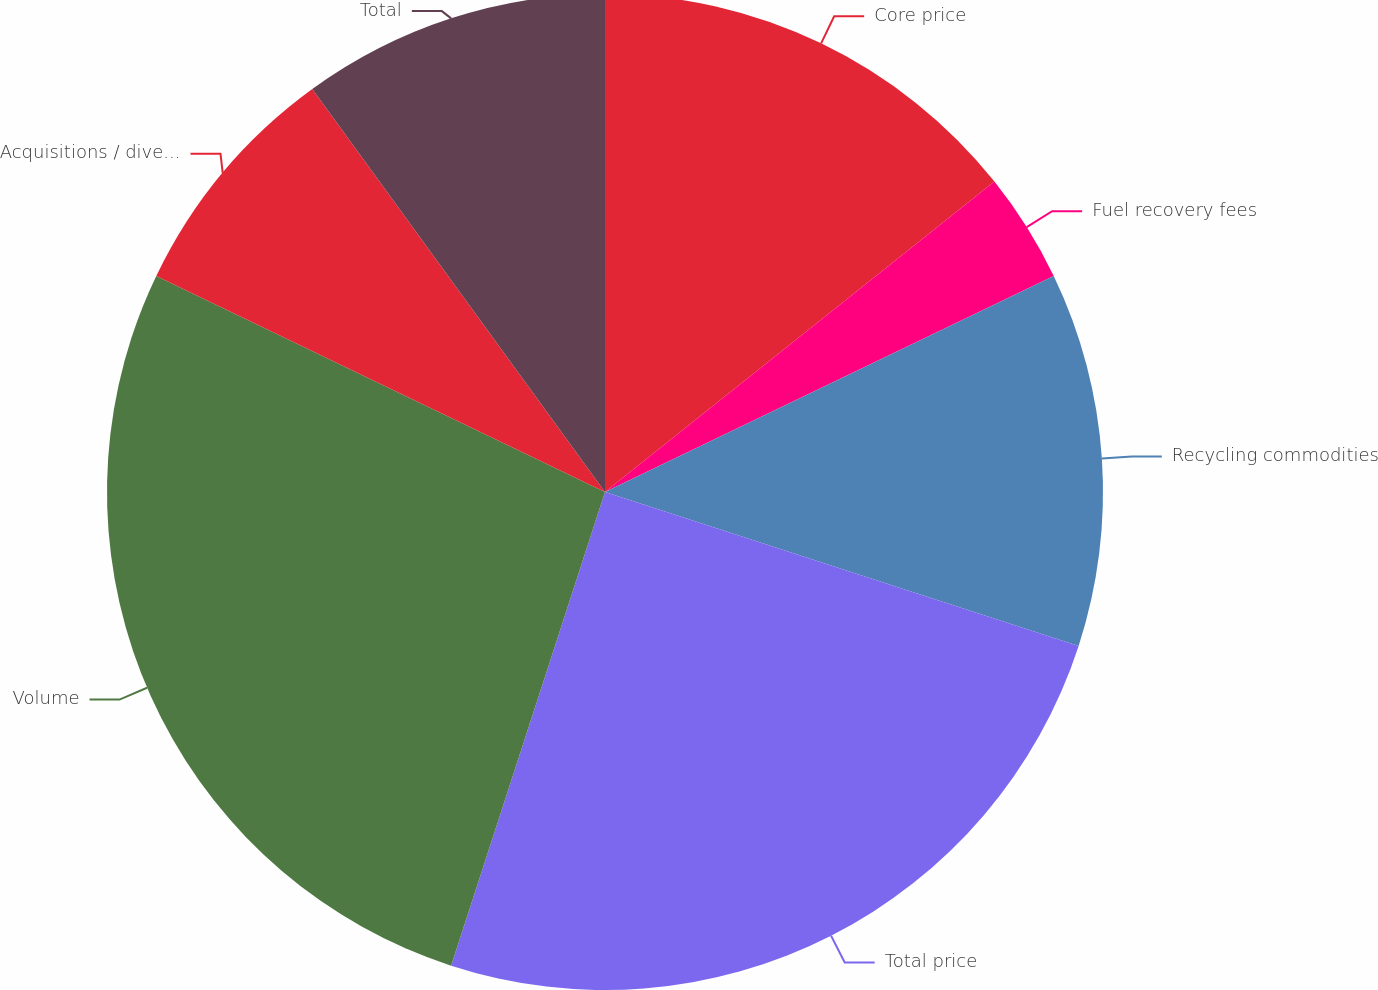<chart> <loc_0><loc_0><loc_500><loc_500><pie_chart><fcel>Core price<fcel>Fuel recovery fees<fcel>Recycling commodities<fcel>Total price<fcel>Volume<fcel>Acquisitions / divestitures<fcel>Total<nl><fcel>14.29%<fcel>3.57%<fcel>12.14%<fcel>25.0%<fcel>27.14%<fcel>7.86%<fcel>10.0%<nl></chart> 